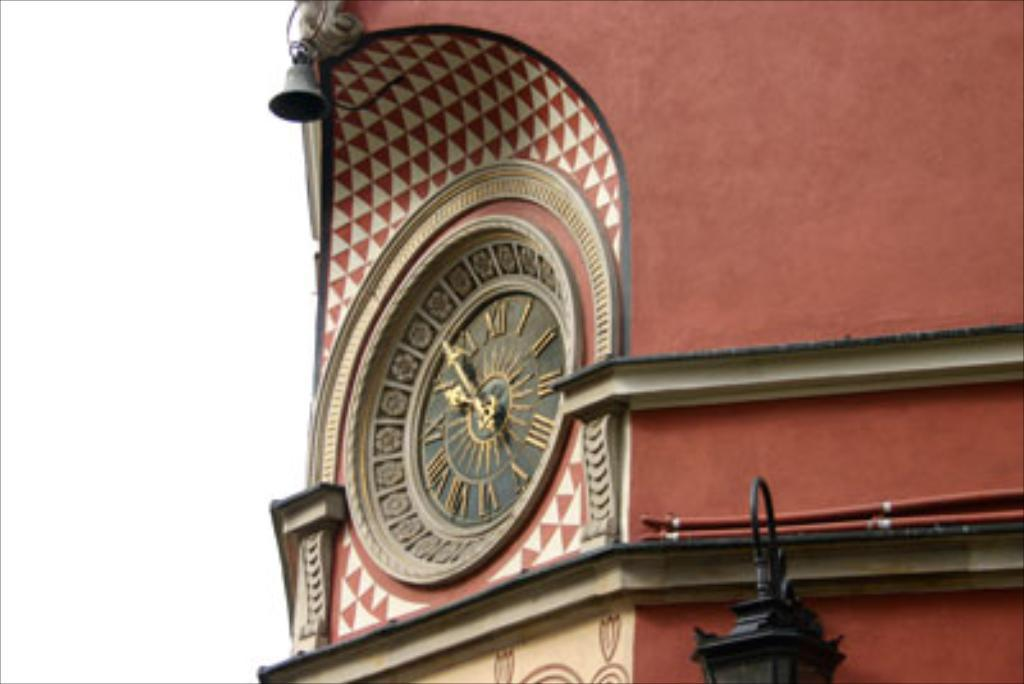What object can be seen on the wall in the image? There is a clock on the wall in the image. What object is at the top of the image? There is a bell at the top of the image. What object is at the bottom of the image? There is a light at the bottom of the image. What type of structure might the image depict? The image appears to depict a building. Can you tell me how many chess pieces are on the window ledge in the image? There is no window or chess pieces present in the image. 